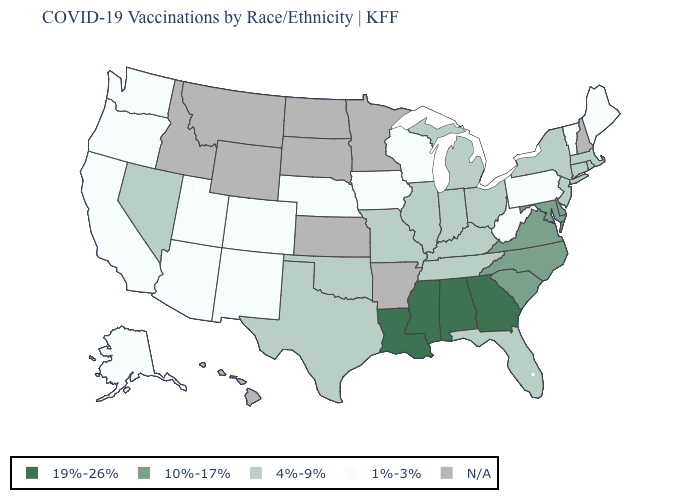Which states have the lowest value in the USA?
Answer briefly. Alaska, Arizona, California, Colorado, Iowa, Maine, Nebraska, New Mexico, Oregon, Pennsylvania, Utah, Vermont, Washington, West Virginia, Wisconsin. What is the lowest value in the USA?
Be succinct. 1%-3%. Which states hav the highest value in the West?
Keep it brief. Nevada. Does the first symbol in the legend represent the smallest category?
Write a very short answer. No. Name the states that have a value in the range N/A?
Write a very short answer. Arkansas, Hawaii, Idaho, Kansas, Minnesota, Montana, New Hampshire, North Dakota, South Dakota, Wyoming. Among the states that border Arizona , which have the lowest value?
Concise answer only. California, Colorado, New Mexico, Utah. Name the states that have a value in the range 19%-26%?
Give a very brief answer. Alabama, Georgia, Louisiana, Mississippi. Is the legend a continuous bar?
Keep it brief. No. Name the states that have a value in the range 19%-26%?
Give a very brief answer. Alabama, Georgia, Louisiana, Mississippi. Name the states that have a value in the range 1%-3%?
Give a very brief answer. Alaska, Arizona, California, Colorado, Iowa, Maine, Nebraska, New Mexico, Oregon, Pennsylvania, Utah, Vermont, Washington, West Virginia, Wisconsin. Name the states that have a value in the range 4%-9%?
Keep it brief. Connecticut, Florida, Illinois, Indiana, Kentucky, Massachusetts, Michigan, Missouri, Nevada, New Jersey, New York, Ohio, Oklahoma, Rhode Island, Tennessee, Texas. Which states have the lowest value in the MidWest?
Short answer required. Iowa, Nebraska, Wisconsin. What is the value of Wisconsin?
Give a very brief answer. 1%-3%. 